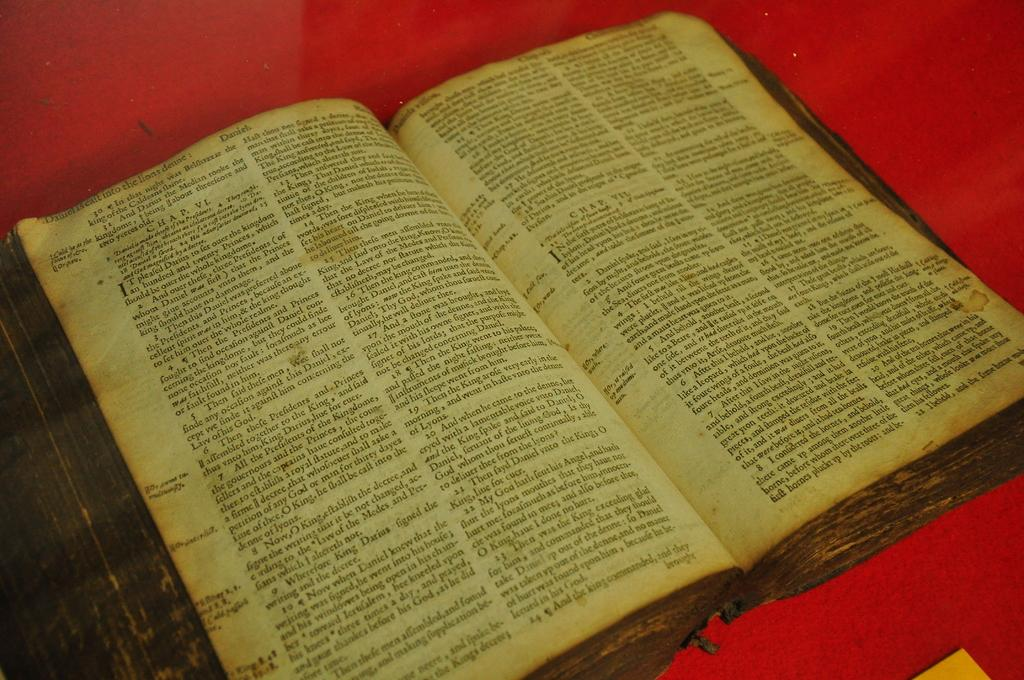Provide a one-sentence caption for the provided image. Book open on a page that says "Daniel is caft into the lions denne" near the top. 